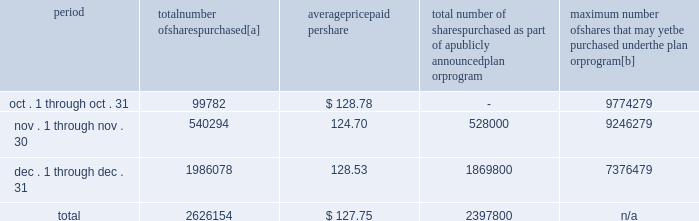Five-year performance comparison 2013 the following graph provides an indicator of cumulative total shareholder returns for the corporation as compared to the peer group index ( described above ) , the dow jones , and the s&p 500 .
The graph assumes that the value of the investment in the common stock of union pacific corporation and each index was $ 100 on december 31 , 2002 , and that all dividends were reinvested .
Comparison of five-year cumulative return 2002 2003 2004 2005 2006 2007 upc s&p 500 peer group dj trans purchases of equity securities 2013 during 2007 , we repurchased 13266070 shares of our common stock at an average price of $ 115.66 .
During the first nine months of 2007 , we repurchased 10639916 shares of our common stock at an average price per share of $ 112.68 .
The table presents common stock repurchases during each month for the fourth quarter of 2007 : period number of shares purchased average paid per total number of shares purchased as part of a publicly announced plan or program maximum number of shares that may yet be purchased under the plan or program .
[a] total number of shares purchased during the quarter includes 228354 shares delivered or attested to upc by employees to pay stock option exercise prices , satisfy excess tax withholding obligations for stock option exercises or vesting of retention units , and pay withholding obligations for vesting of retention shares .
[b] on january 30 , 2007 , our board of directors authorized us to repurchase up to 20 million shares of our common stock through december 31 , 2009 .
We may make these repurchases on the open market or through other transactions .
Our management has sole discretion with respect to determining the timing and amount of these transactions. .
What percentage of the total number of shares purchased were purchased in december? 
Computations: (1986078 / 2626154)
Answer: 0.75627. 